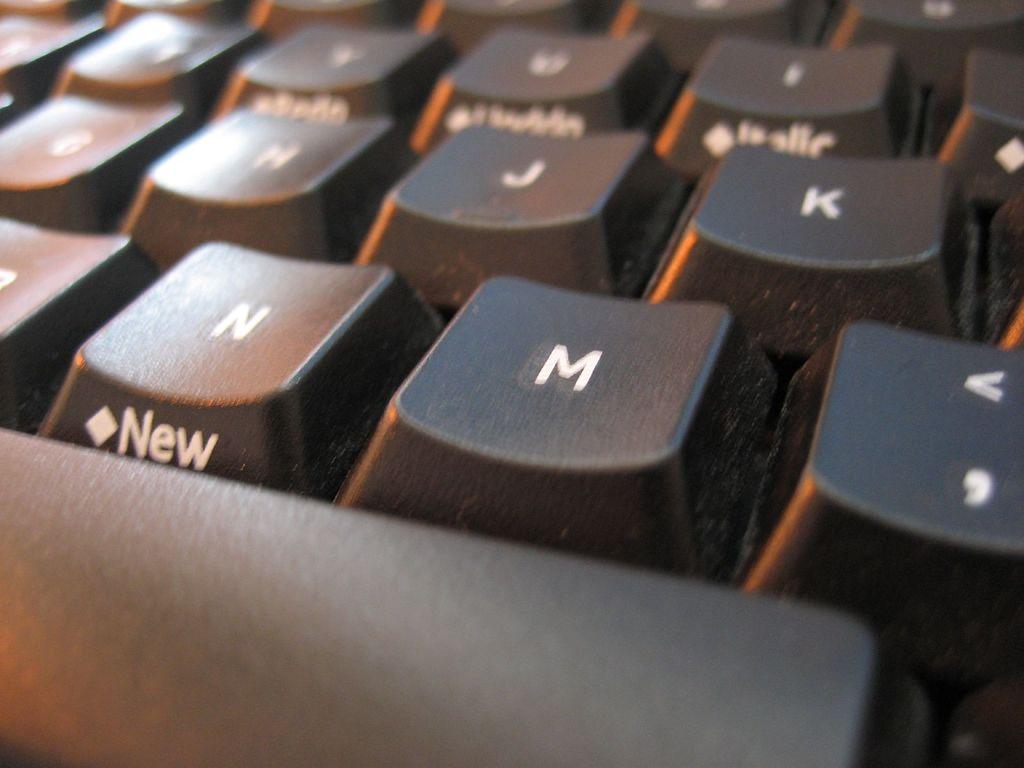What does the n button say below it?
Offer a terse response. New. 